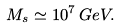Convert formula to latex. <formula><loc_0><loc_0><loc_500><loc_500>M _ { s } \simeq 1 0 ^ { 7 } \, G e V .</formula> 